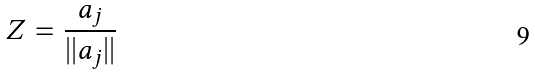Convert formula to latex. <formula><loc_0><loc_0><loc_500><loc_500>Z = \frac { a _ { j } } { | | a _ { j } | | }</formula> 